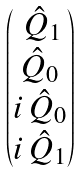Convert formula to latex. <formula><loc_0><loc_0><loc_500><loc_500>\begin{pmatrix} \, { \hat { Q } } _ { 1 } \\ { \hat { Q } } _ { 0 } \\ i \, { \hat { Q } } _ { 0 } \\ i \, { \hat { Q } } _ { 1 } \end{pmatrix}</formula> 